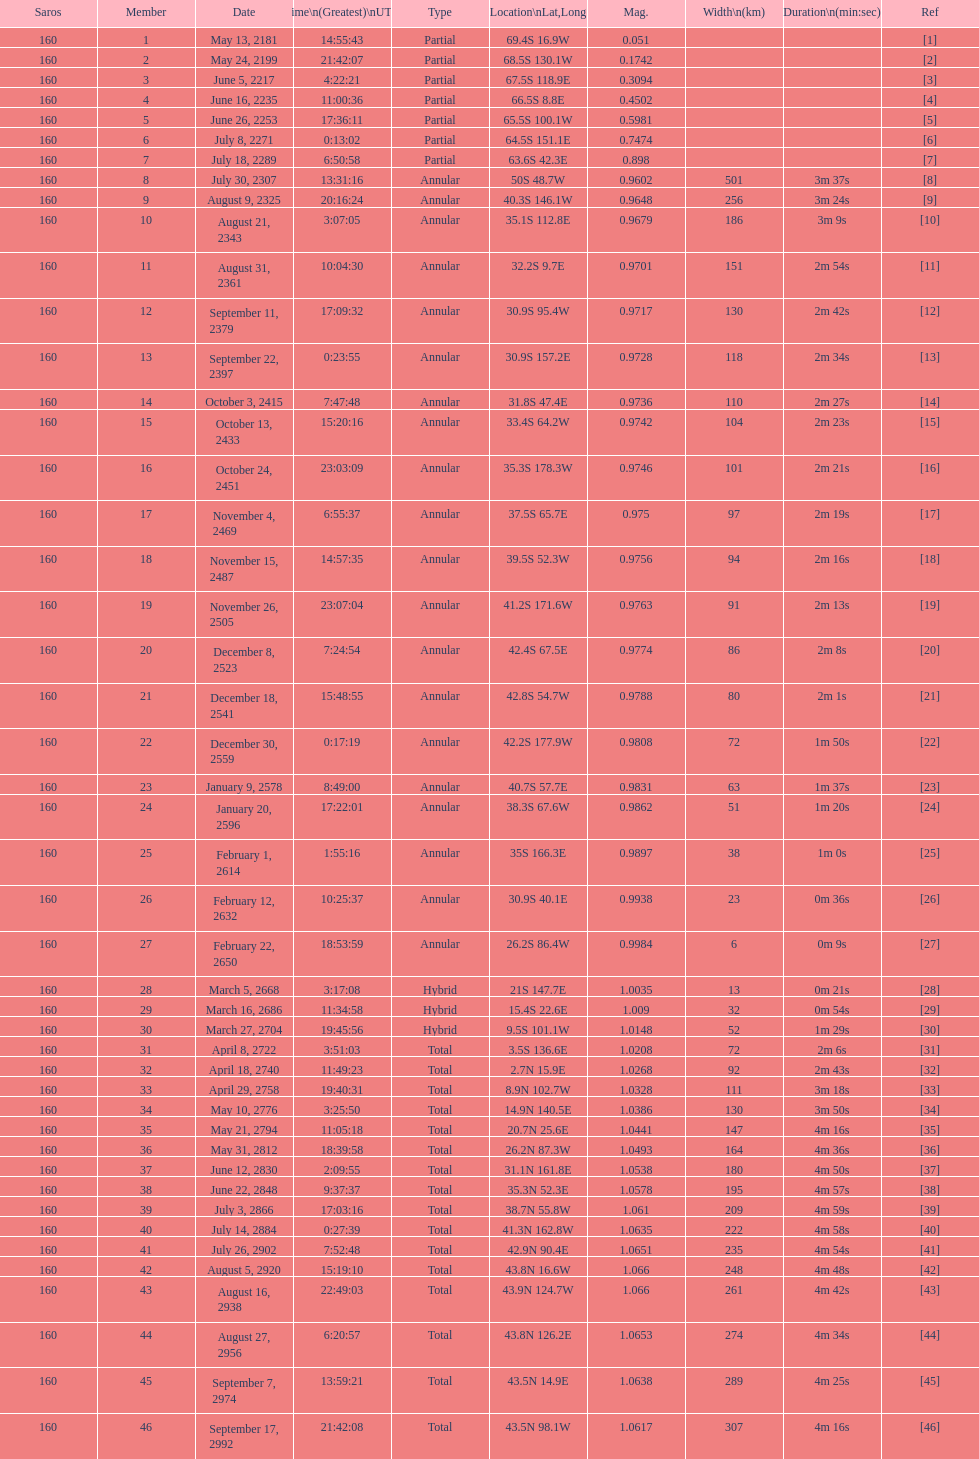How many partial members will occur before the first annular? 7. 